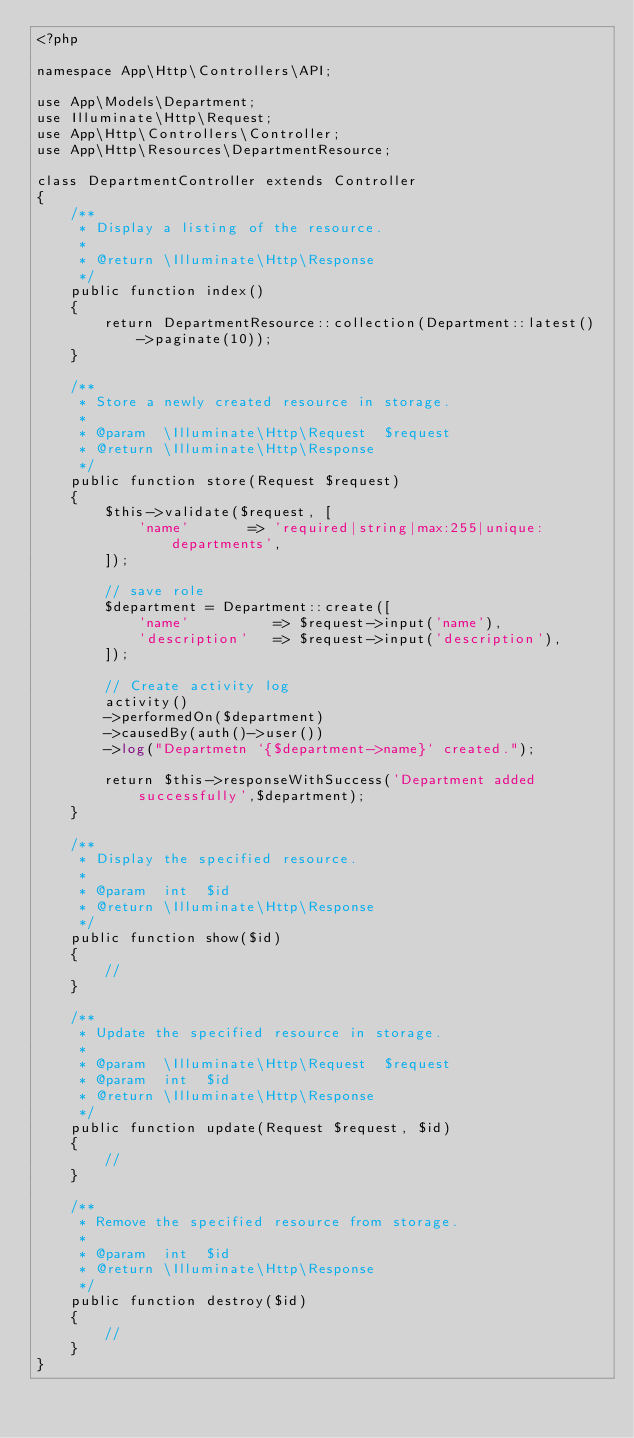<code> <loc_0><loc_0><loc_500><loc_500><_PHP_><?php

namespace App\Http\Controllers\API;

use App\Models\Department;
use Illuminate\Http\Request;
use App\Http\Controllers\Controller;
use App\Http\Resources\DepartmentResource;

class DepartmentController extends Controller
{
    /**
     * Display a listing of the resource.
     *
     * @return \Illuminate\Http\Response
     */
    public function index()
    {
        return DepartmentResource::collection(Department::latest()->paginate(10));
    }

    /**
     * Store a newly created resource in storage.
     *
     * @param  \Illuminate\Http\Request  $request
     * @return \Illuminate\Http\Response
     */
    public function store(Request $request)
    {
        $this->validate($request, [
            'name'       => 'required|string|max:255|unique:departments',
        ]);

        // save role
        $department = Department::create([
            'name'          => $request->input('name'),
            'description'   => $request->input('description'),
        ]);

        // Create activity log 
        activity()
        ->performedOn($department)
        ->causedBy(auth()->user())
        ->log("Departmetn `{$department->name}` created.");

        return $this->responseWithSuccess('Department added successfully',$department);
    }

    /**
     * Display the specified resource.
     *
     * @param  int  $id
     * @return \Illuminate\Http\Response
     */
    public function show($id)
    {
        //
    }

    /**
     * Update the specified resource in storage.
     *
     * @param  \Illuminate\Http\Request  $request
     * @param  int  $id
     * @return \Illuminate\Http\Response
     */
    public function update(Request $request, $id)
    {
        //
    }

    /**
     * Remove the specified resource from storage.
     *
     * @param  int  $id
     * @return \Illuminate\Http\Response
     */
    public function destroy($id)
    {
        //
    }
}
</code> 